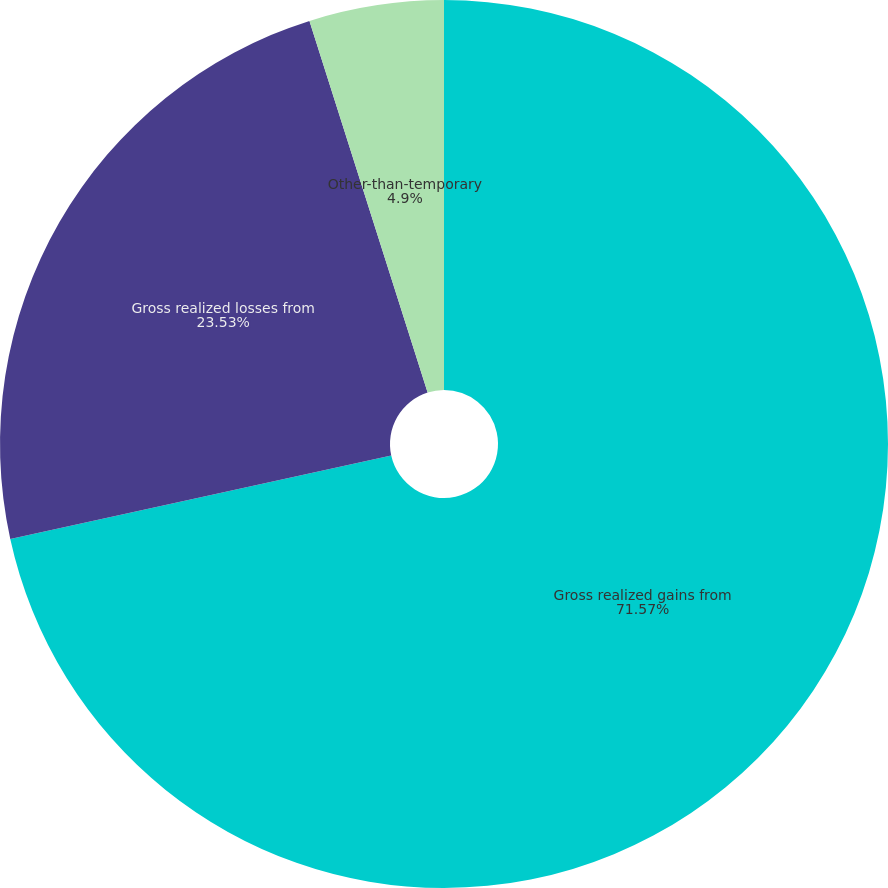Convert chart. <chart><loc_0><loc_0><loc_500><loc_500><pie_chart><fcel>Gross realized gains from<fcel>Gross realized losses from<fcel>Other-than-temporary<nl><fcel>71.57%<fcel>23.53%<fcel>4.9%<nl></chart> 